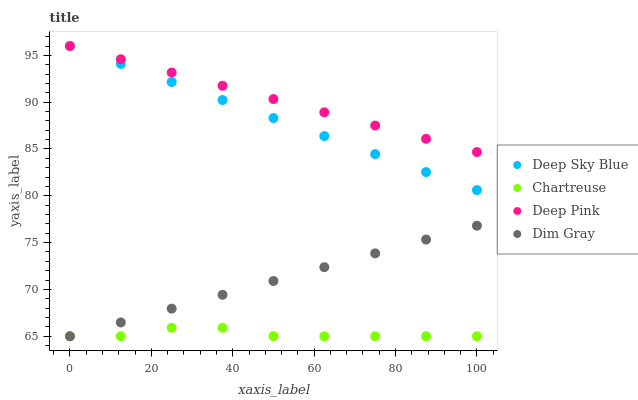Does Chartreuse have the minimum area under the curve?
Answer yes or no. Yes. Does Deep Pink have the maximum area under the curve?
Answer yes or no. Yes. Does Deep Pink have the minimum area under the curve?
Answer yes or no. No. Does Chartreuse have the maximum area under the curve?
Answer yes or no. No. Is Dim Gray the smoothest?
Answer yes or no. Yes. Is Chartreuse the roughest?
Answer yes or no. Yes. Is Deep Pink the smoothest?
Answer yes or no. No. Is Deep Pink the roughest?
Answer yes or no. No. Does Dim Gray have the lowest value?
Answer yes or no. Yes. Does Deep Pink have the lowest value?
Answer yes or no. No. Does Deep Sky Blue have the highest value?
Answer yes or no. Yes. Does Chartreuse have the highest value?
Answer yes or no. No. Is Dim Gray less than Deep Pink?
Answer yes or no. Yes. Is Deep Sky Blue greater than Chartreuse?
Answer yes or no. Yes. Does Dim Gray intersect Chartreuse?
Answer yes or no. Yes. Is Dim Gray less than Chartreuse?
Answer yes or no. No. Is Dim Gray greater than Chartreuse?
Answer yes or no. No. Does Dim Gray intersect Deep Pink?
Answer yes or no. No. 